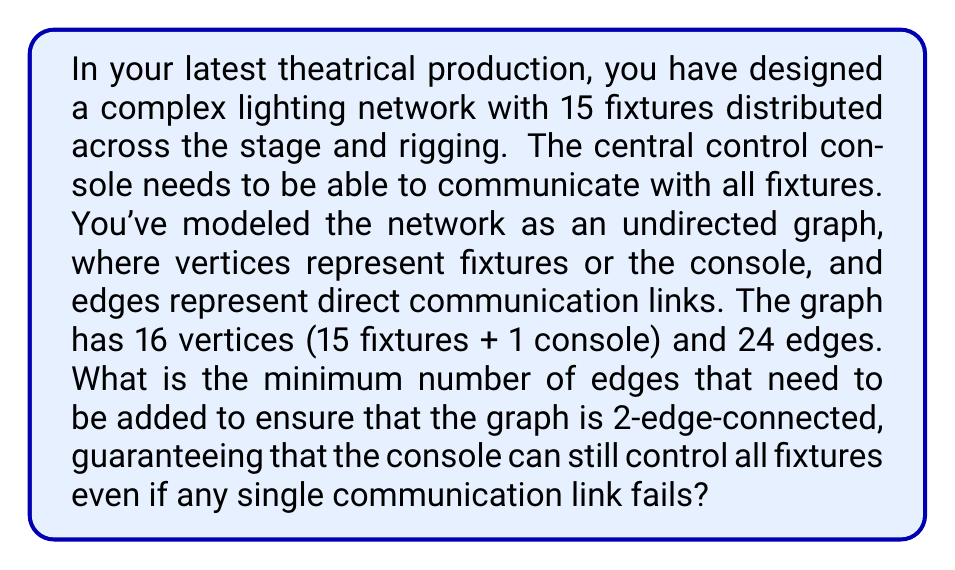Could you help me with this problem? To solve this problem, we need to understand the concept of k-edge-connectivity in graph theory and apply it to our lighting network.

1. Given information:
   - Number of vertices, $V = 16$ (15 fixtures + 1 console)
   - Number of edges, $E = 24$

2. Definition of 2-edge-connectivity:
   A graph is 2-edge-connected if it remains connected after the removal of any single edge.

3. Theorem: For a graph to be 2-edge-connected, it must have at least $\lceil \frac{3n}{2} \rceil$ edges, where $n$ is the number of vertices.

4. Calculate the minimum number of edges required:
   $$\text{Minimum edges} = \left\lceil \frac{3n}{2} \right\rceil = \left\lceil \frac{3 \cdot 16}{2} \right\rceil = \lceil 24 \rceil = 24$$

5. Compare the current number of edges to the minimum required:
   Current edges: 24
   Minimum required: 24

6. Calculate the number of edges to be added:
   Edges to be added = Minimum required - Current edges
   $$24 - 24 = 0$$

Therefore, the graph already has the minimum number of edges required for 2-edge-connectivity. However, this doesn't guarantee that the graph is actually 2-edge-connected; it only meets the necessary condition.

To ensure 2-edge-connectivity, we need to check if there are any bridge edges (edges whose removal would disconnect the graph). If there are any bridge edges, we need to add one edge for each bridge to create an alternative path.

In the worst-case scenario, all 24 edges could be bridges. In this case, we would need to add 24 new edges to make the graph 2-edge-connected.

In the best-case scenario, the graph is already 2-edge-connected, and we don't need to add any edges.

Without more information about the specific structure of the graph, we can only provide the range of possible answers: between 0 and 24 edges need to be added.
Answer: The minimum number of edges that need to be added to ensure 2-edge-connectivity is between 0 and 24, depending on the current structure of the graph. To determine the exact number, we would need to analyze the graph for bridge edges. 